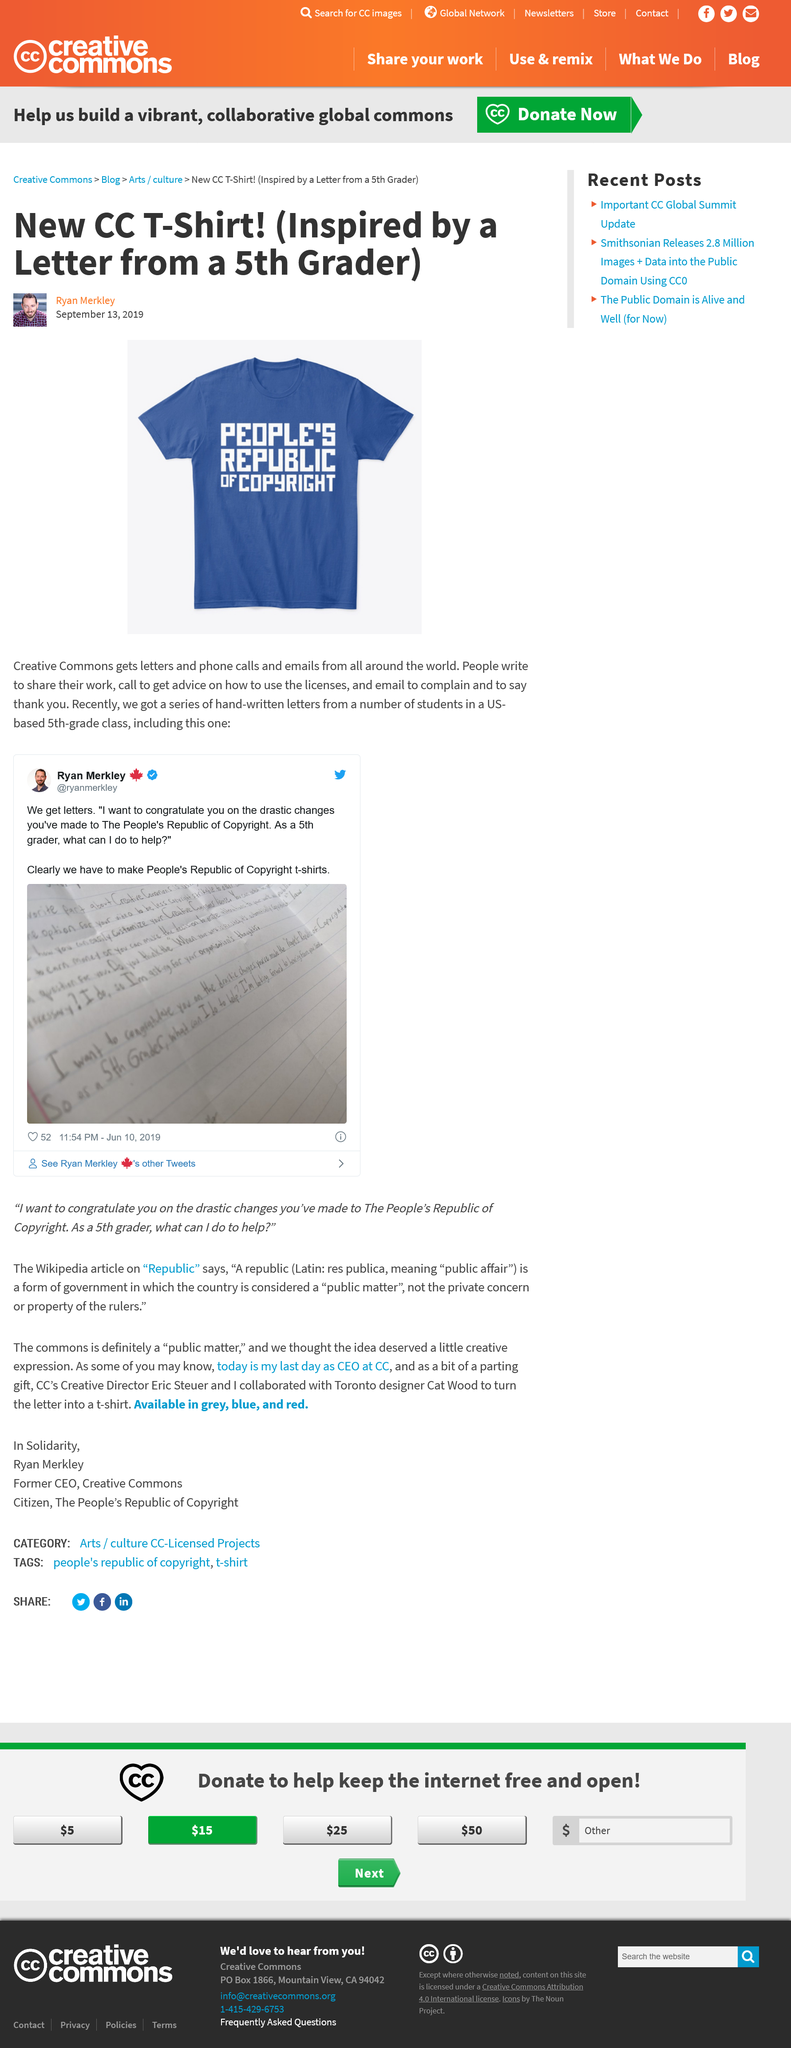Identify some key points in this picture. People seek advice on how to use licenses by calling for assistance. The 5th-grade class who sent letters based was located in the United States. The article of clothing in the image was inspired by a 5th grader. 